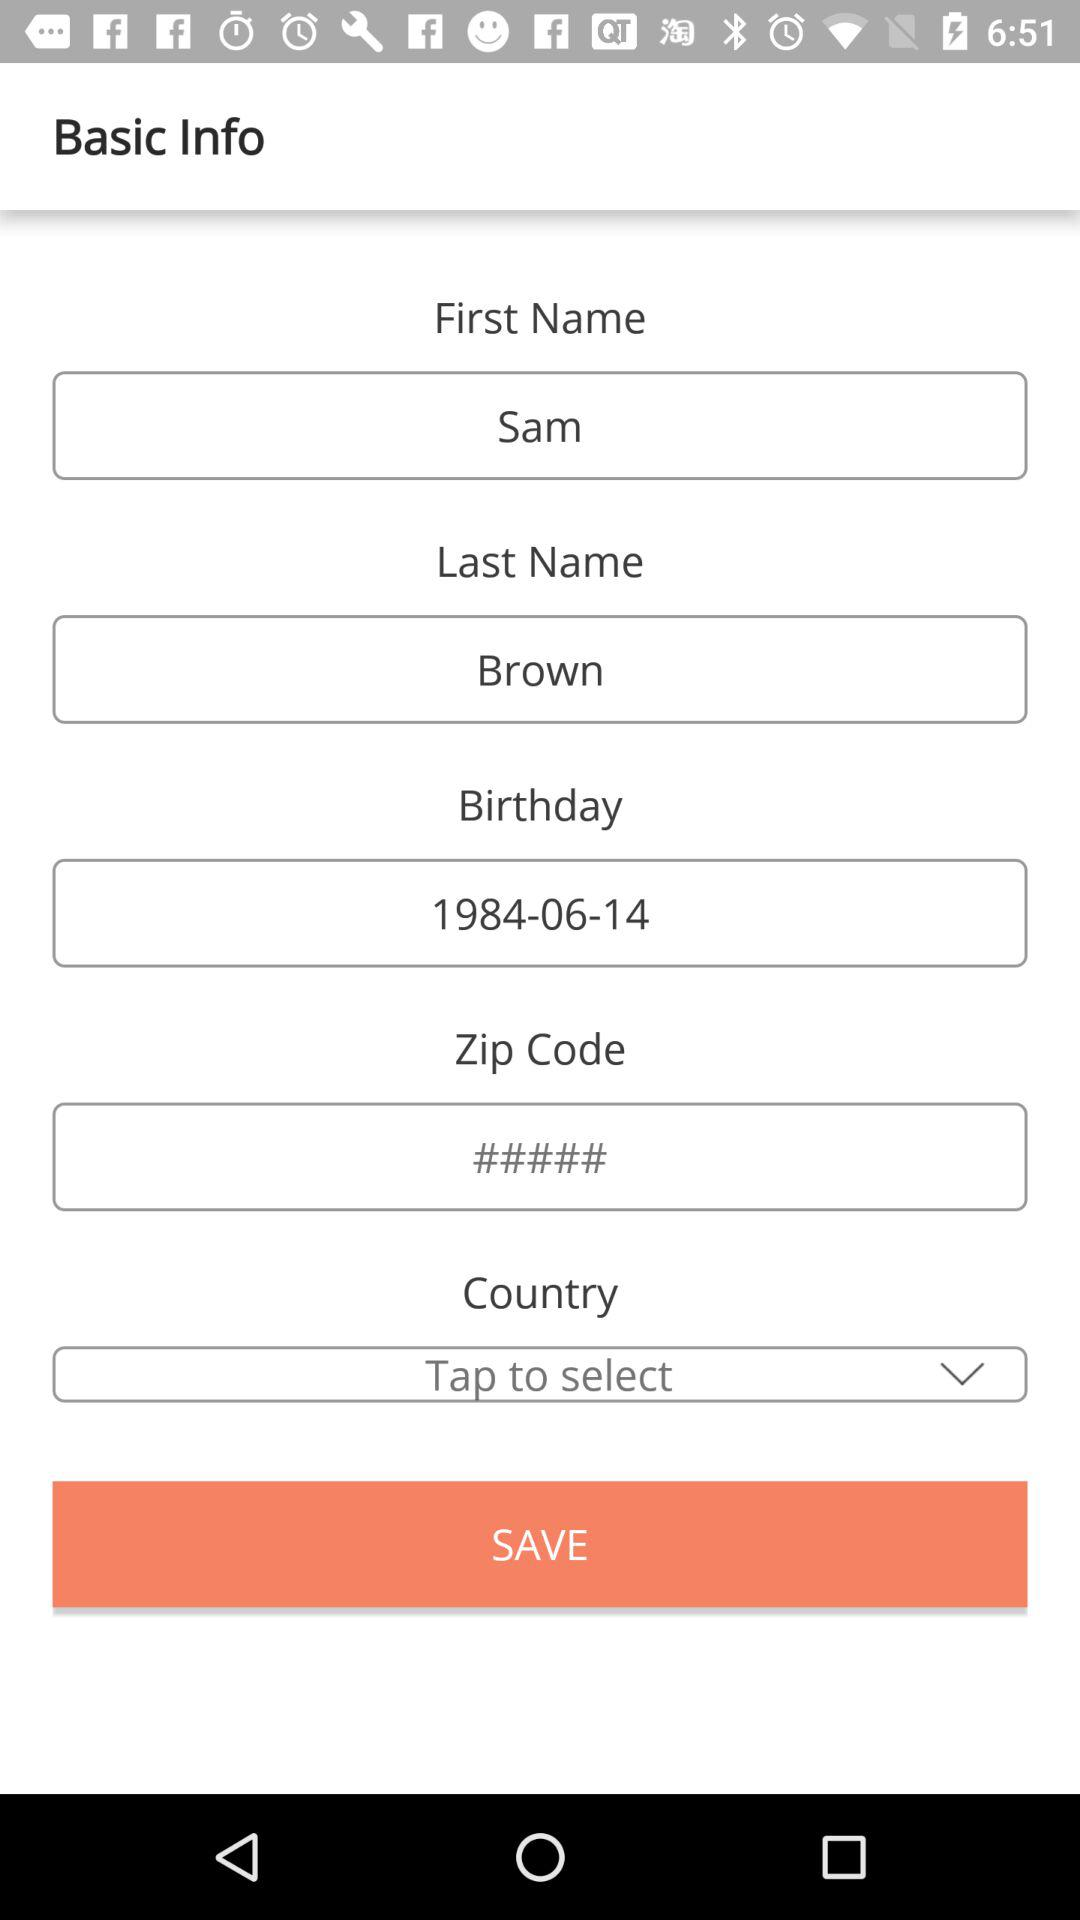What is the date of birth? The date of birth is June 14, 1984. 